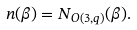<formula> <loc_0><loc_0><loc_500><loc_500>n ( \beta ) = N _ { O ( 3 , q ) } ( \beta ) .</formula> 